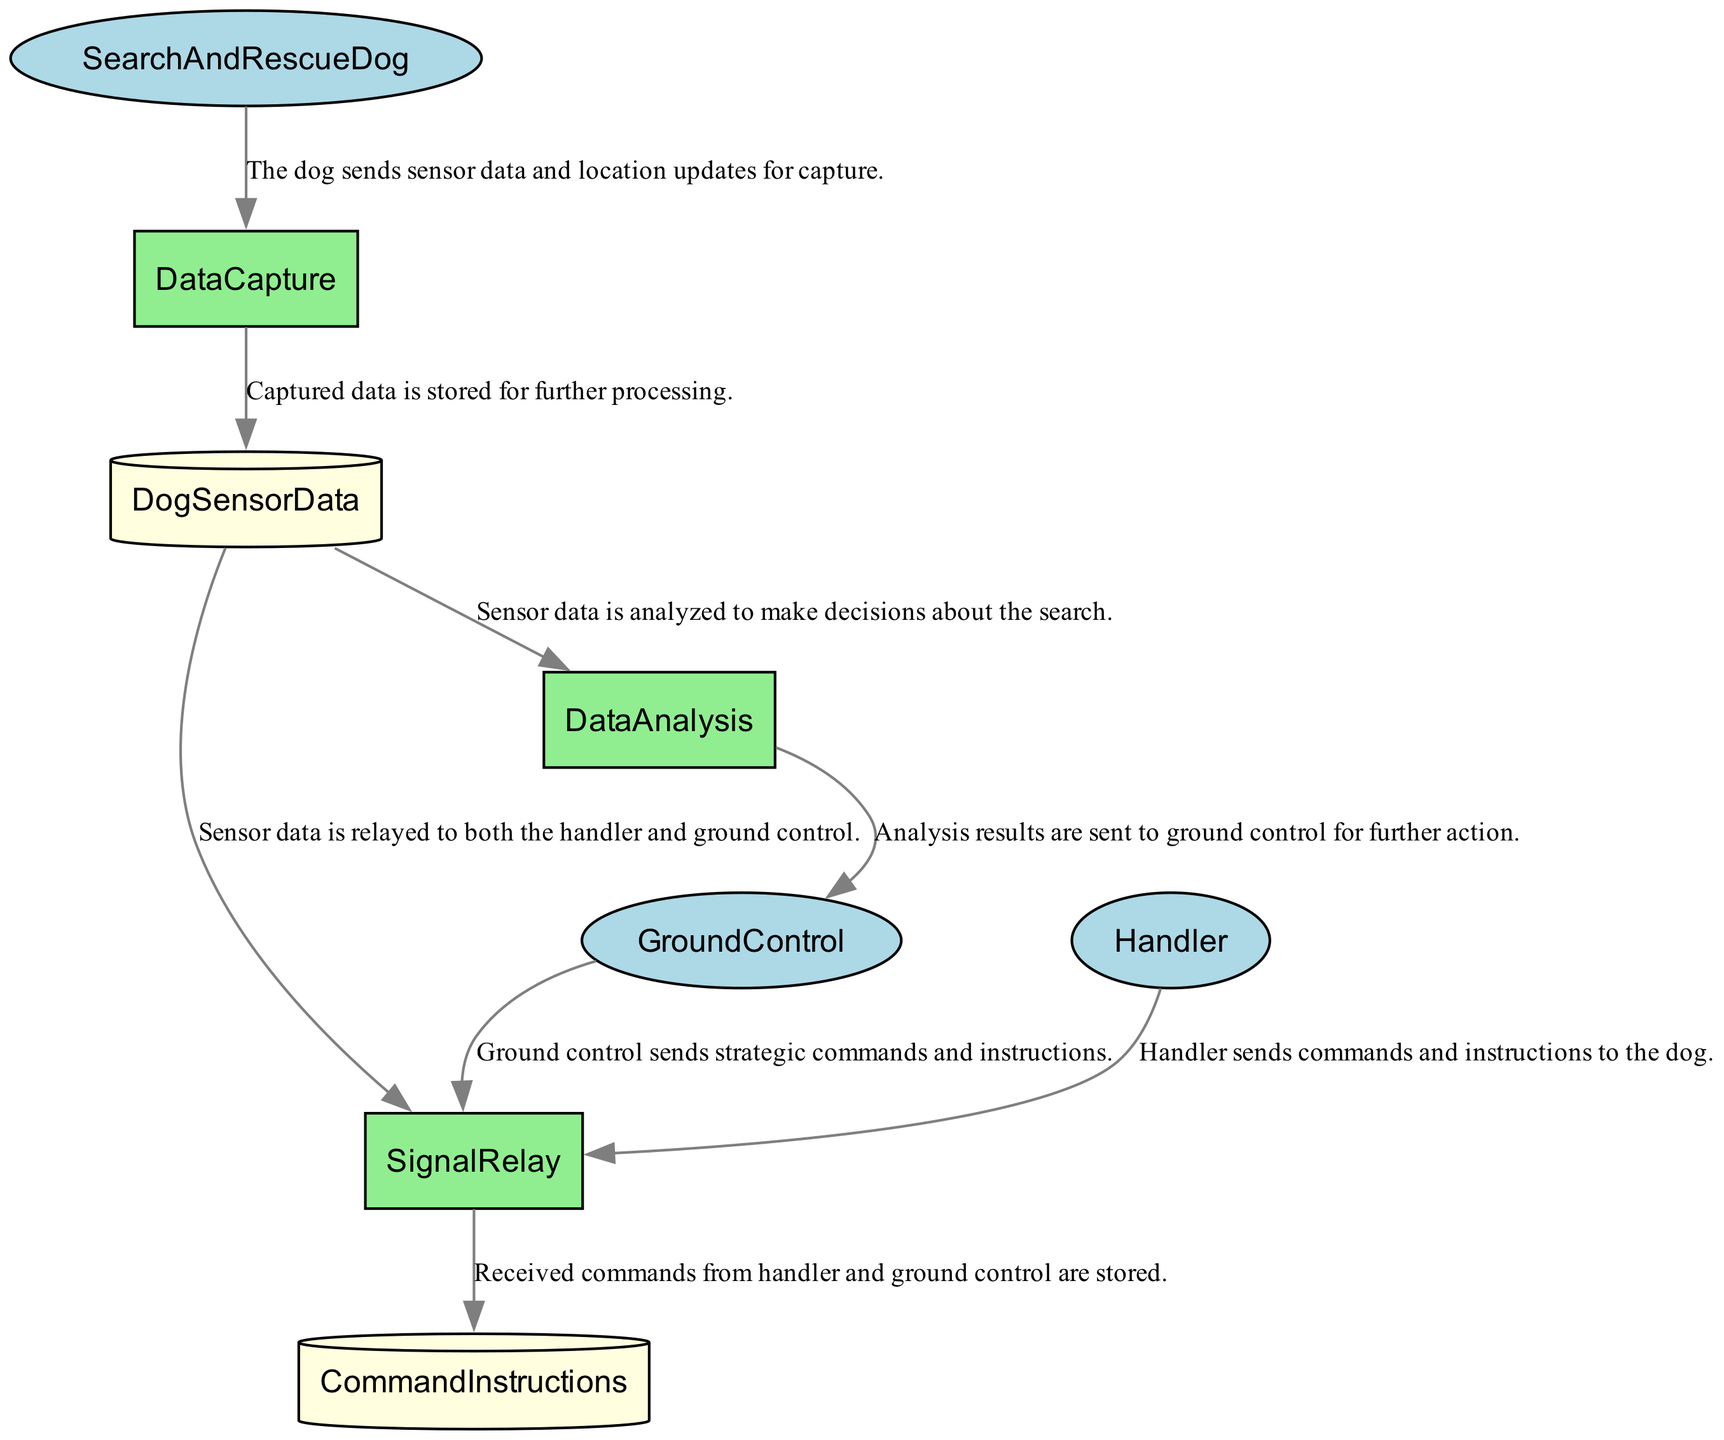What is the first process in the data flow? The first process in the diagram is "DataCapture," which receives data from the SearchAndRescueDog.
Answer: DataCapture How many external entities are present in the diagram? The diagram includes three external entities: SearchAndRescueDog, Handler, and GroundControl.
Answer: 3 What data store holds the sensor data? The data store that holds the sensor data is called "DogSensorData."
Answer: DogSensorData Who sends commands to the SignalRelay process? Both the Handler and GroundControl send commands to the SignalRelay process.
Answer: Handler and GroundControl Which process receives data from DogSensorData? The process that receives data from DogSensorData is "DataAnalysis."
Answer: DataAnalysis What is the last process to send data in the flow? The last process to send data in the flow is the "DataAnalysis," which sends results to GroundControl.
Answer: DataAnalysis How many data flows originate from the DataCapture process? Two data flows originate from the DataCapture process, directing data to DogSensorData and SignalRelay.
Answer: 2 What is the relationship between the SignalRelay and CommandInstructions? The SignalRelay process stores received commands into the "CommandInstructions" data store.
Answer: Stores What type of diagram is being depicted here? The diagram depicted here is a Data Flow Diagram.
Answer: Data Flow Diagram 